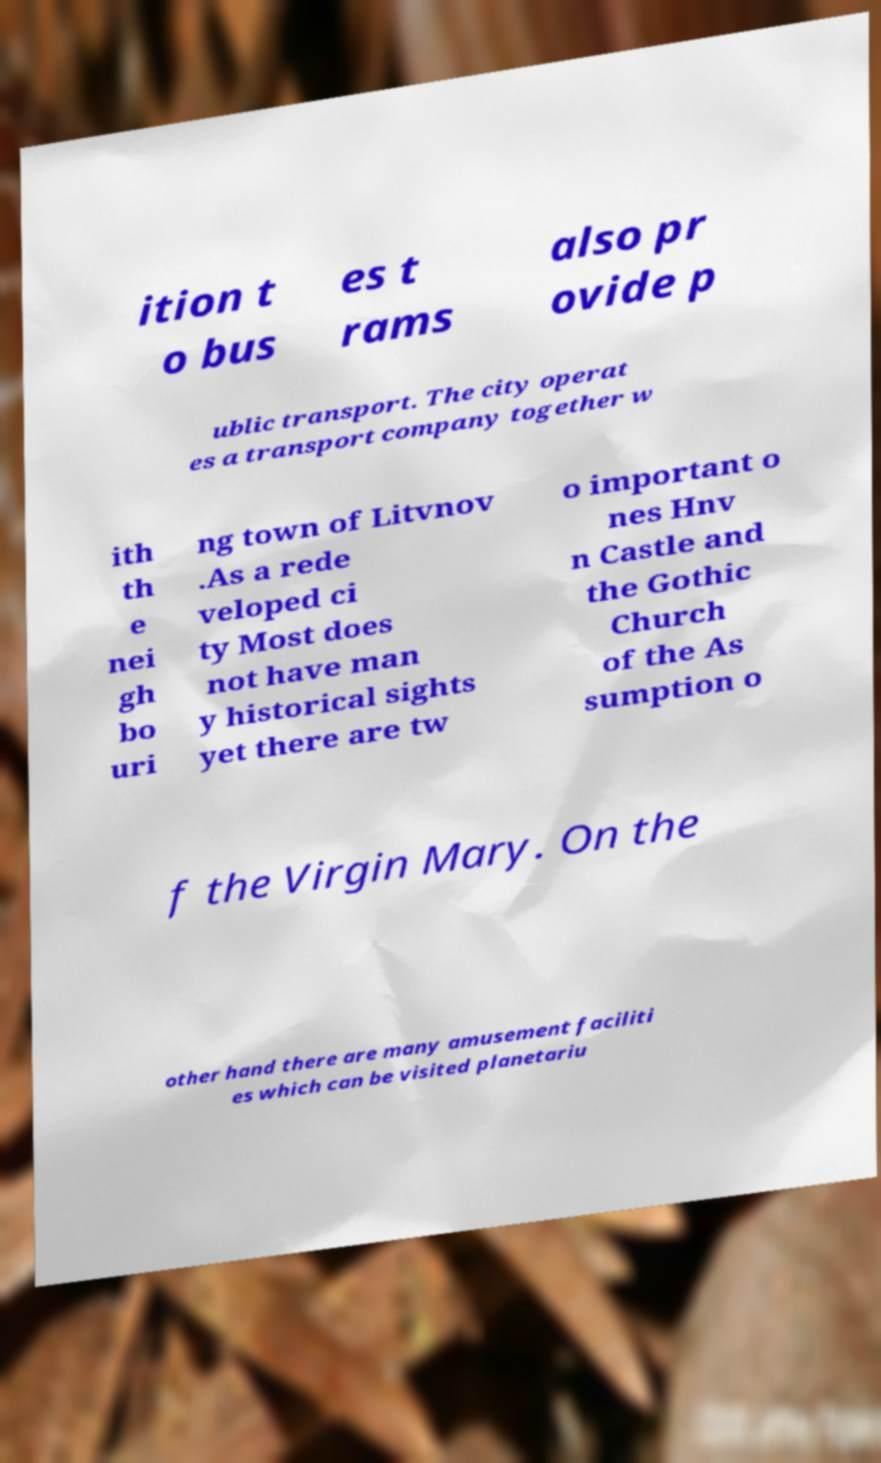There's text embedded in this image that I need extracted. Can you transcribe it verbatim? ition t o bus es t rams also pr ovide p ublic transport. The city operat es a transport company together w ith th e nei gh bo uri ng town of Litvnov .As a rede veloped ci ty Most does not have man y historical sights yet there are tw o important o nes Hnv n Castle and the Gothic Church of the As sumption o f the Virgin Mary. On the other hand there are many amusement faciliti es which can be visited planetariu 